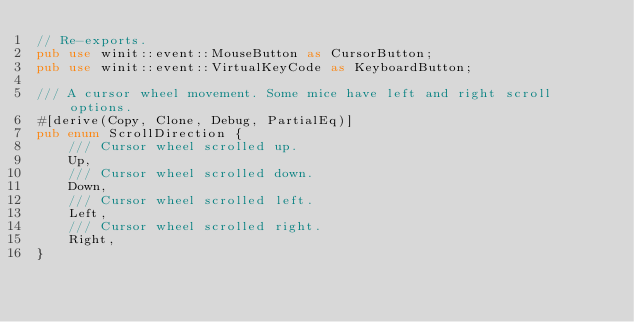<code> <loc_0><loc_0><loc_500><loc_500><_Rust_>// Re-exports.
pub use winit::event::MouseButton as CursorButton;
pub use winit::event::VirtualKeyCode as KeyboardButton;

/// A cursor wheel movement. Some mice have left and right scroll options.
#[derive(Copy, Clone, Debug, PartialEq)]
pub enum ScrollDirection {
    /// Cursor wheel scrolled up.
    Up,
    /// Cursor wheel scrolled down.
    Down,
    /// Cursor wheel scrolled left.
    Left,
    /// Cursor wheel scrolled right.
    Right,
}
</code> 